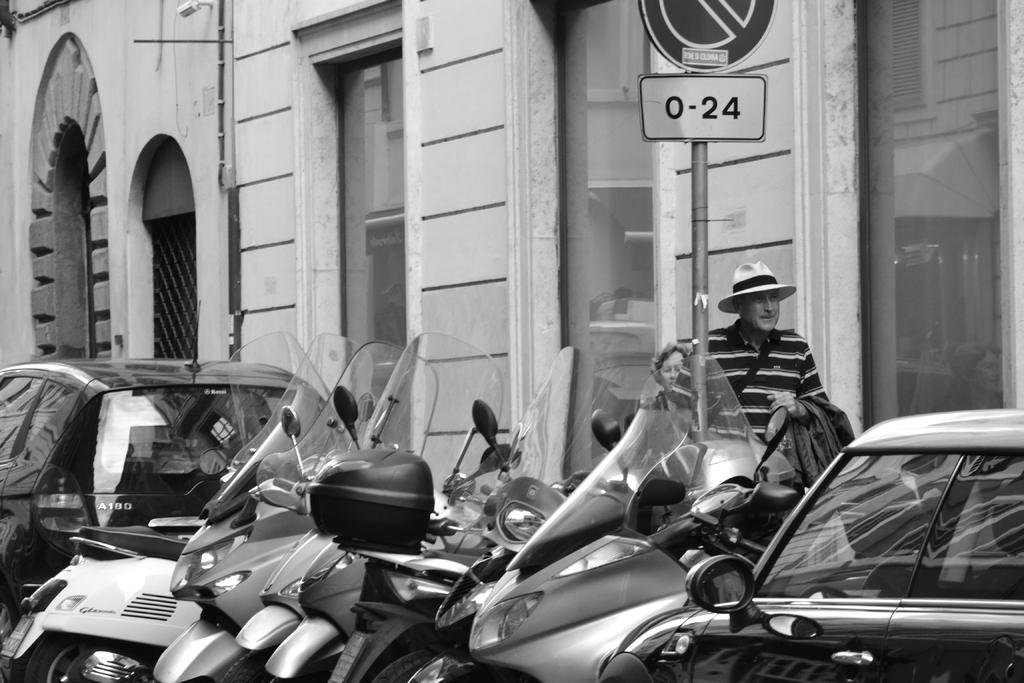What types of vehicles are in the foreground of the image? There are motorbikes and cars in the foreground of the image. What can be seen on the sign board in the foreground of the image? The content of the sign board is not mentioned in the facts, so we cannot determine what is on it. How many people are visible in the image? There are two people visible in the image. What type of building is present in the image? The building in the image has glass windows and arches. What type of art can be seen on the dinosaurs in the image? There are no dinosaurs present in the image, so there is no art to be seen on them. 